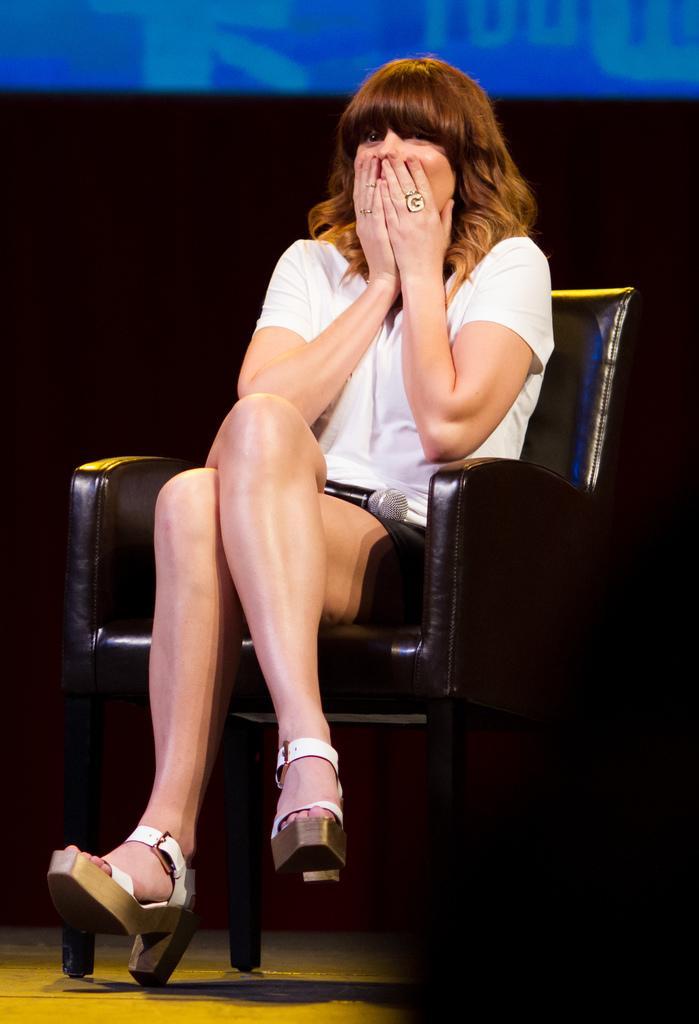How would you summarize this image in a sentence or two? As we can see in the image there is a woman wearing white color dress and sitting on chair. In the background there is screen. 